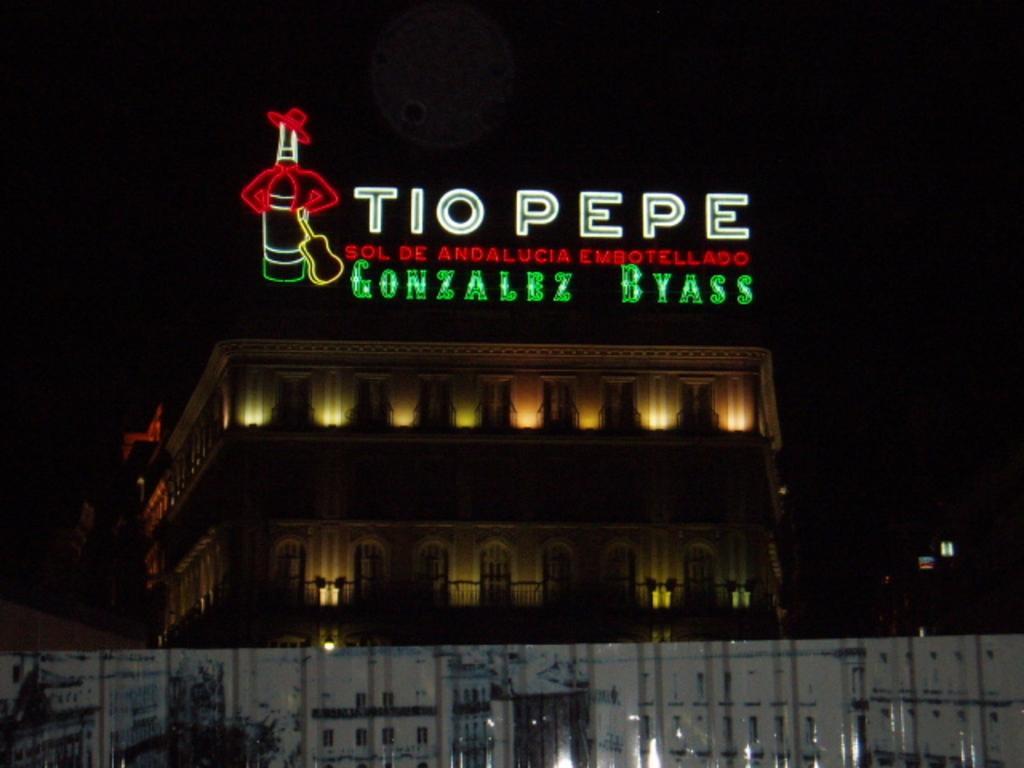Can you describe this image briefly? In the image I can a building and these are the windows of the building. I can see LED text and the dark background. 